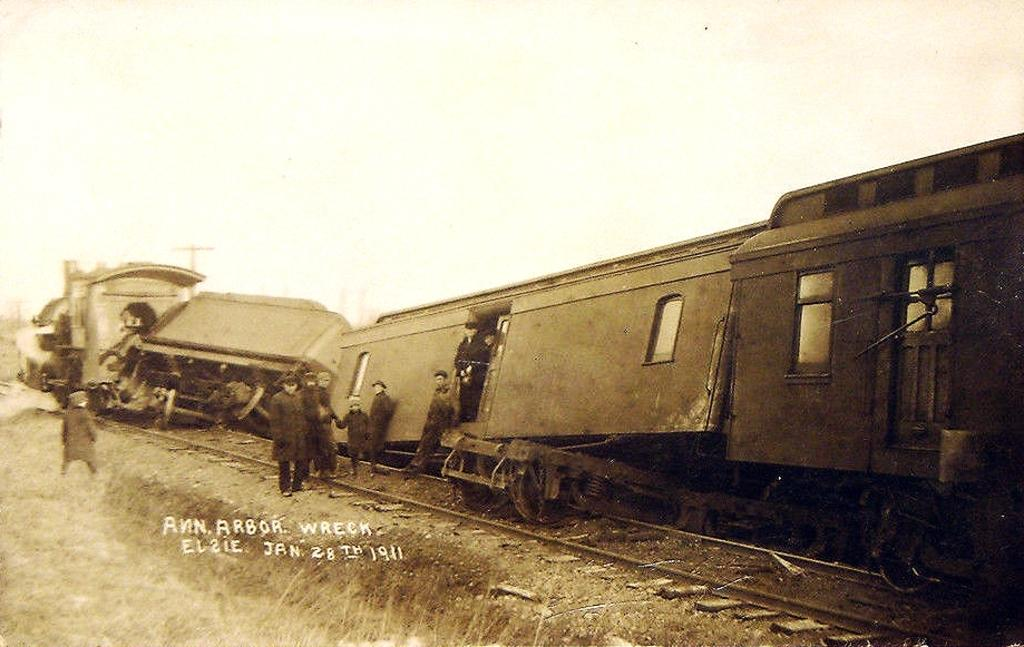What is the main subject in the foreground of the image? There is a train in the foreground of the image. Is the train on the correct path? No, the train is not on the correct path. What can be seen outside the train? There are persons outside the train. What is visible in the background of the image? There are poles and the sky visible in the background of the image. What type of education is being discussed by the grain in the image? There is no grain present in the image, and therefore no discussion about education can be observed. 